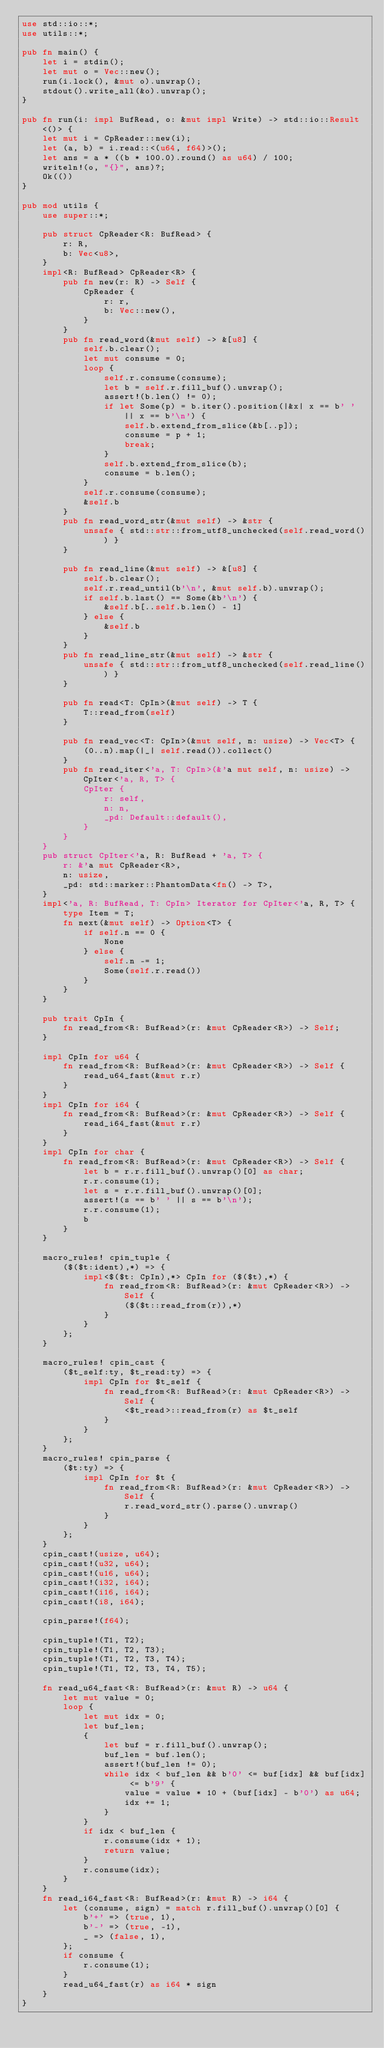Convert code to text. <code><loc_0><loc_0><loc_500><loc_500><_Rust_>use std::io::*;
use utils::*;

pub fn main() {
    let i = stdin();
    let mut o = Vec::new();
    run(i.lock(), &mut o).unwrap();
    stdout().write_all(&o).unwrap();
}

pub fn run(i: impl BufRead, o: &mut impl Write) -> std::io::Result<()> {
    let mut i = CpReader::new(i);
    let (a, b) = i.read::<(u64, f64)>();
    let ans = a * ((b * 100.0).round() as u64) / 100;
    writeln!(o, "{}", ans)?;
    Ok(())
}

pub mod utils {
    use super::*;

    pub struct CpReader<R: BufRead> {
        r: R,
        b: Vec<u8>,
    }
    impl<R: BufRead> CpReader<R> {
        pub fn new(r: R) -> Self {
            CpReader {
                r: r,
                b: Vec::new(),
            }
        }
        pub fn read_word(&mut self) -> &[u8] {
            self.b.clear();
            let mut consume = 0;
            loop {
                self.r.consume(consume);
                let b = self.r.fill_buf().unwrap();
                assert!(b.len() != 0);
                if let Some(p) = b.iter().position(|&x| x == b' ' || x == b'\n') {
                    self.b.extend_from_slice(&b[..p]);
                    consume = p + 1;
                    break;
                }
                self.b.extend_from_slice(b);
                consume = b.len();
            }
            self.r.consume(consume);
            &self.b
        }
        pub fn read_word_str(&mut self) -> &str {
            unsafe { std::str::from_utf8_unchecked(self.read_word()) }
        }

        pub fn read_line(&mut self) -> &[u8] {
            self.b.clear();
            self.r.read_until(b'\n', &mut self.b).unwrap();
            if self.b.last() == Some(&b'\n') {
                &self.b[..self.b.len() - 1]
            } else {
                &self.b
            }
        }
        pub fn read_line_str(&mut self) -> &str {
            unsafe { std::str::from_utf8_unchecked(self.read_line()) }
        }

        pub fn read<T: CpIn>(&mut self) -> T {
            T::read_from(self)
        }

        pub fn read_vec<T: CpIn>(&mut self, n: usize) -> Vec<T> {
            (0..n).map(|_| self.read()).collect()
        }
        pub fn read_iter<'a, T: CpIn>(&'a mut self, n: usize) -> CpIter<'a, R, T> {
            CpIter {
                r: self,
                n: n,
                _pd: Default::default(),
            }
        }
    }
    pub struct CpIter<'a, R: BufRead + 'a, T> {
        r: &'a mut CpReader<R>,
        n: usize,
        _pd: std::marker::PhantomData<fn() -> T>,
    }
    impl<'a, R: BufRead, T: CpIn> Iterator for CpIter<'a, R, T> {
        type Item = T;
        fn next(&mut self) -> Option<T> {
            if self.n == 0 {
                None
            } else {
                self.n -= 1;
                Some(self.r.read())
            }
        }
    }

    pub trait CpIn {
        fn read_from<R: BufRead>(r: &mut CpReader<R>) -> Self;
    }

    impl CpIn for u64 {
        fn read_from<R: BufRead>(r: &mut CpReader<R>) -> Self {
            read_u64_fast(&mut r.r)
        }
    }
    impl CpIn for i64 {
        fn read_from<R: BufRead>(r: &mut CpReader<R>) -> Self {
            read_i64_fast(&mut r.r)
        }
    }
    impl CpIn for char {
        fn read_from<R: BufRead>(r: &mut CpReader<R>) -> Self {
            let b = r.r.fill_buf().unwrap()[0] as char;
            r.r.consume(1);
            let s = r.r.fill_buf().unwrap()[0];
            assert!(s == b' ' || s == b'\n');
            r.r.consume(1);
            b
        }
    }

    macro_rules! cpin_tuple {
        ($($t:ident),*) => {
            impl<$($t: CpIn),*> CpIn for ($($t),*) {
                fn read_from<R: BufRead>(r: &mut CpReader<R>) -> Self {
                    ($($t::read_from(r)),*)
                }
            }
        };
    }

    macro_rules! cpin_cast {
        ($t_self:ty, $t_read:ty) => {
            impl CpIn for $t_self {
                fn read_from<R: BufRead>(r: &mut CpReader<R>) -> Self {
                    <$t_read>::read_from(r) as $t_self
                }
            }
        };
    }
    macro_rules! cpin_parse {
        ($t:ty) => {
            impl CpIn for $t {
                fn read_from<R: BufRead>(r: &mut CpReader<R>) -> Self {
                    r.read_word_str().parse().unwrap()
                }
            }
        };
    }
    cpin_cast!(usize, u64);
    cpin_cast!(u32, u64);
    cpin_cast!(u16, u64);
    cpin_cast!(i32, i64);
    cpin_cast!(i16, i64);
    cpin_cast!(i8, i64);

    cpin_parse!(f64);

    cpin_tuple!(T1, T2);
    cpin_tuple!(T1, T2, T3);
    cpin_tuple!(T1, T2, T3, T4);
    cpin_tuple!(T1, T2, T3, T4, T5);

    fn read_u64_fast<R: BufRead>(r: &mut R) -> u64 {
        let mut value = 0;
        loop {
            let mut idx = 0;
            let buf_len;
            {
                let buf = r.fill_buf().unwrap();
                buf_len = buf.len();
                assert!(buf_len != 0);
                while idx < buf_len && b'0' <= buf[idx] && buf[idx] <= b'9' {
                    value = value * 10 + (buf[idx] - b'0') as u64;
                    idx += 1;
                }
            }
            if idx < buf_len {
                r.consume(idx + 1);
                return value;
            }
            r.consume(idx);
        }
    }
    fn read_i64_fast<R: BufRead>(r: &mut R) -> i64 {
        let (consume, sign) = match r.fill_buf().unwrap()[0] {
            b'+' => (true, 1),
            b'-' => (true, -1),
            _ => (false, 1),
        };
        if consume {
            r.consume(1);
        }
        read_u64_fast(r) as i64 * sign
    }
}
</code> 